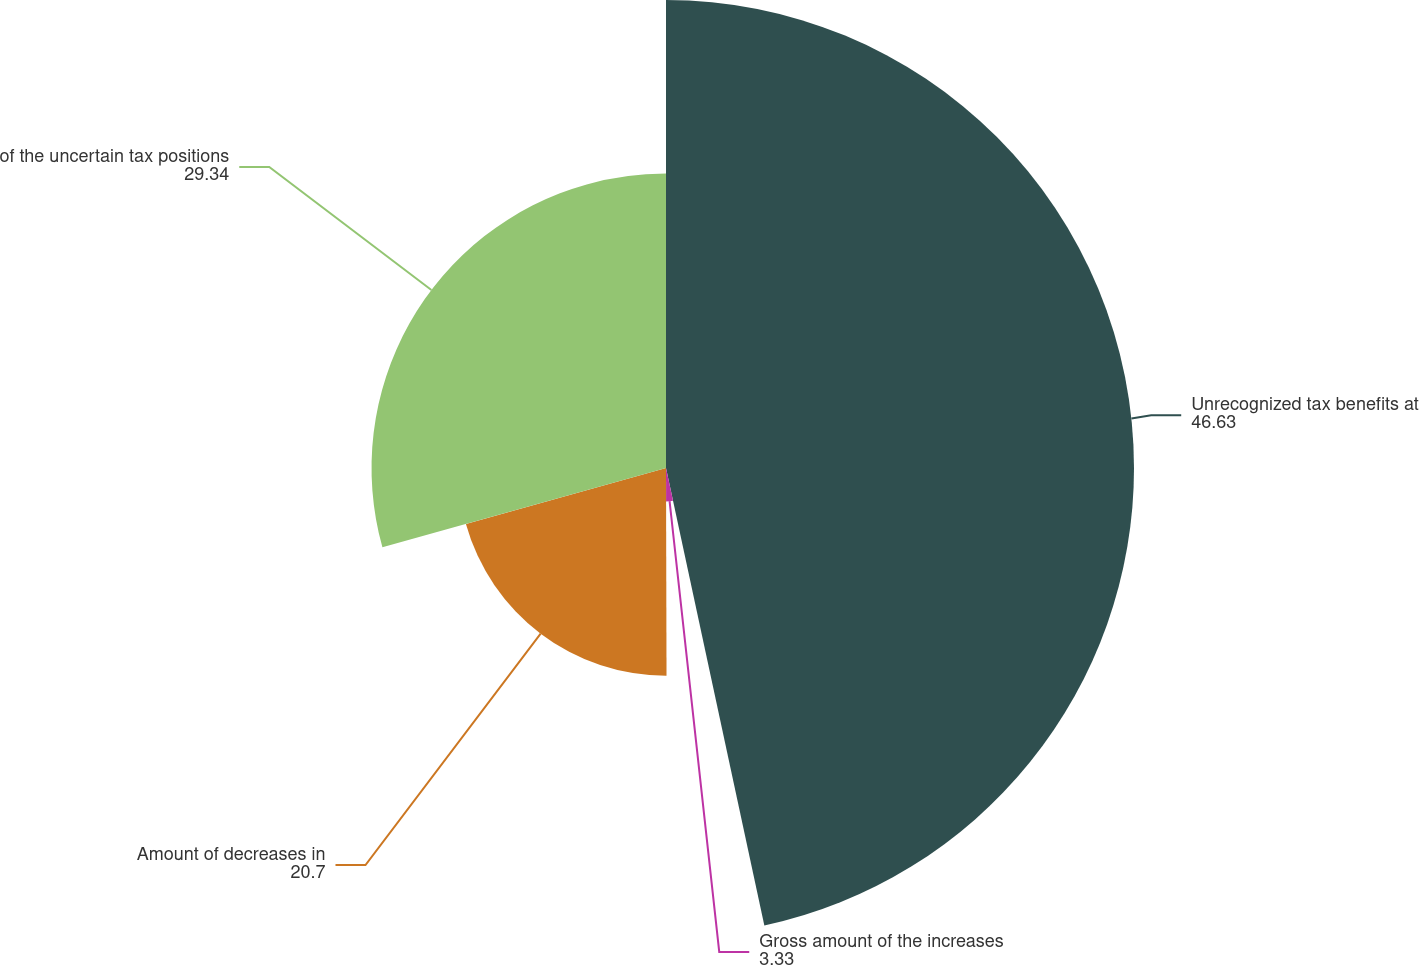Convert chart. <chart><loc_0><loc_0><loc_500><loc_500><pie_chart><fcel>Unrecognized tax benefits at<fcel>Gross amount of the increases<fcel>Amount of decreases in<fcel>of the uncertain tax positions<nl><fcel>46.63%<fcel>3.33%<fcel>20.7%<fcel>29.34%<nl></chart> 